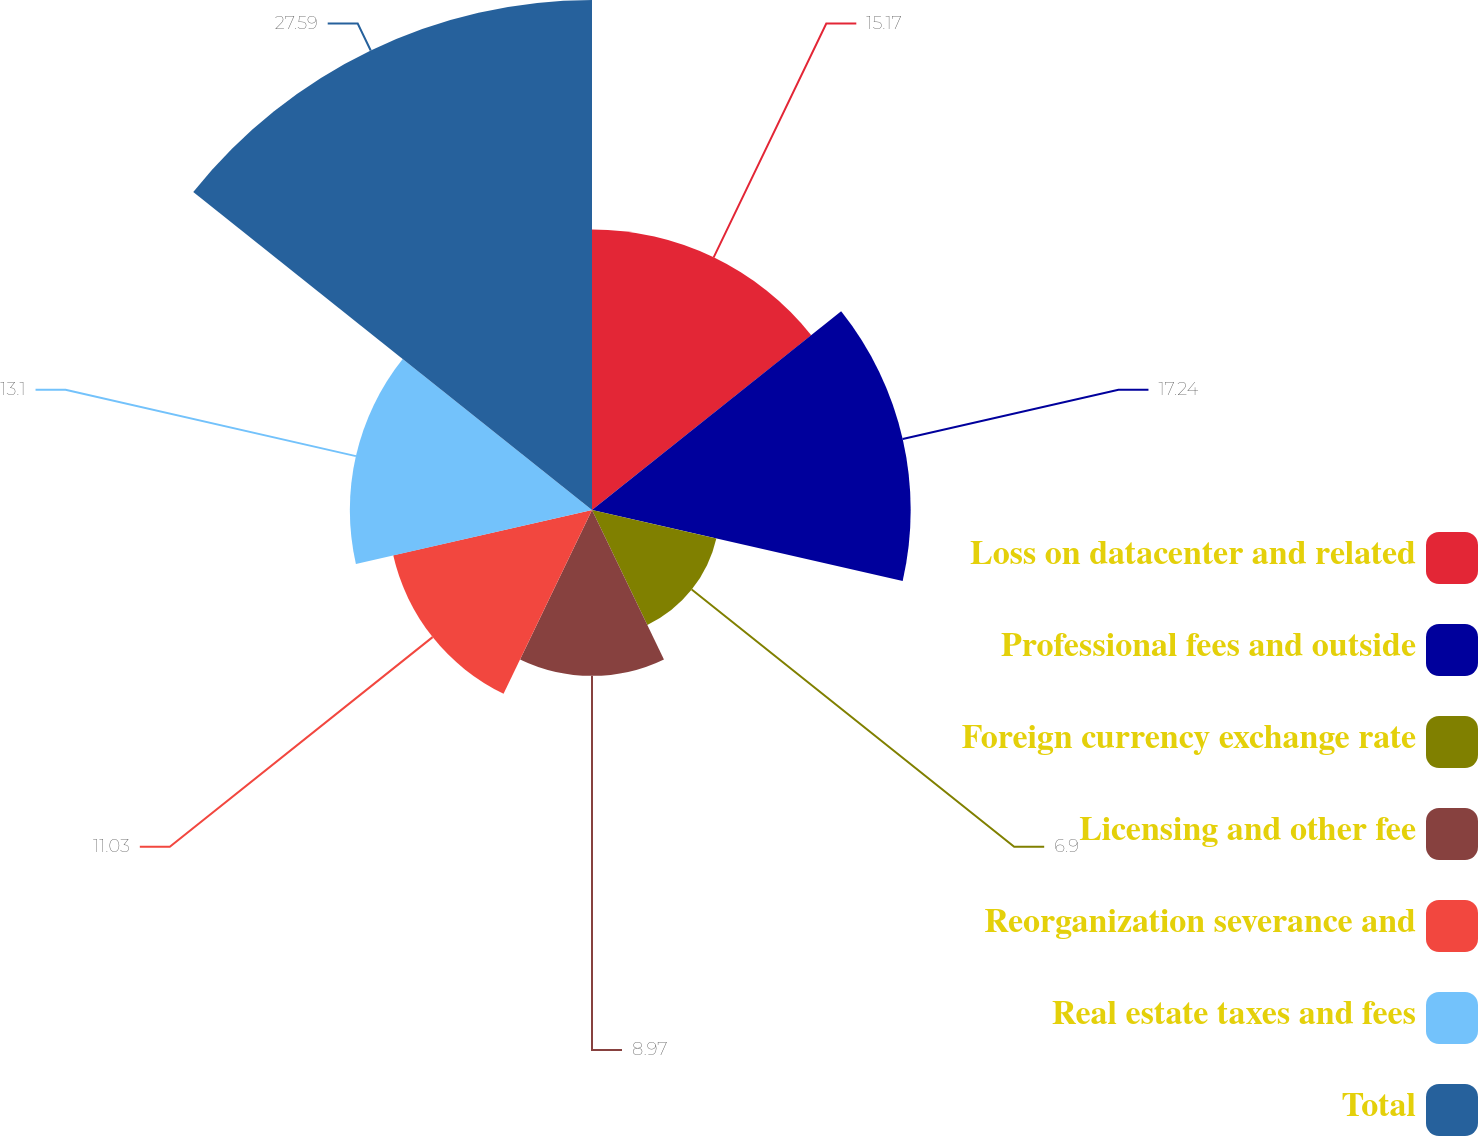<chart> <loc_0><loc_0><loc_500><loc_500><pie_chart><fcel>Loss on datacenter and related<fcel>Professional fees and outside<fcel>Foreign currency exchange rate<fcel>Licensing and other fee<fcel>Reorganization severance and<fcel>Real estate taxes and fees<fcel>Total<nl><fcel>15.17%<fcel>17.24%<fcel>6.9%<fcel>8.97%<fcel>11.03%<fcel>13.1%<fcel>27.59%<nl></chart> 